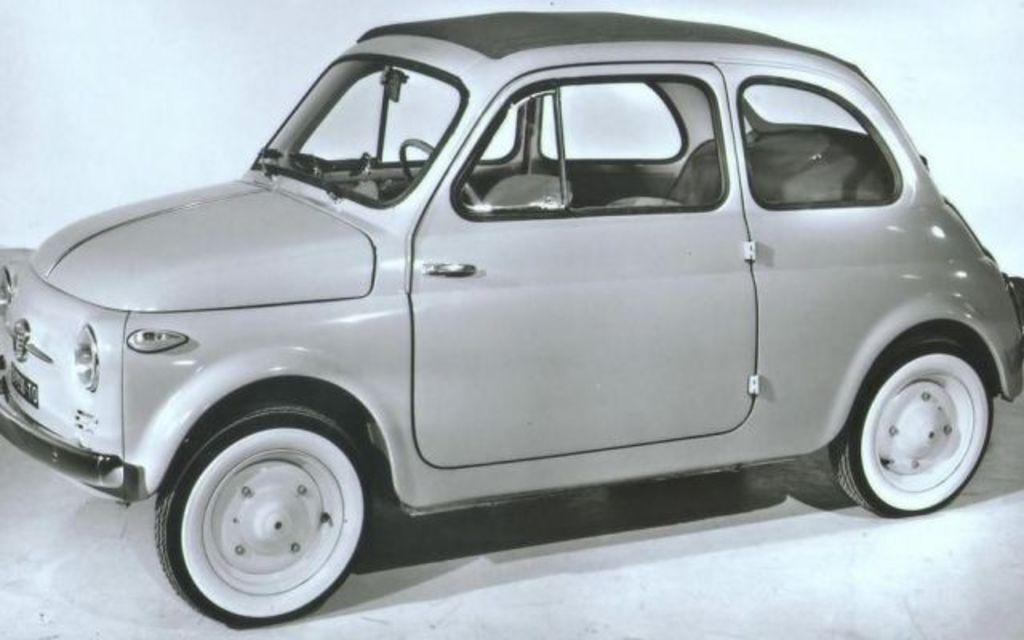What is the color scheme of the image? The image is black and white. What type of vehicle is present in the image? There is a car in the image. What can be seen in the background of the image? There is a wall in the background of the image. What team is represented by the ornament on the car in the image? There is no ornament visible on the car in the image, and therefore no team representation can be observed. 